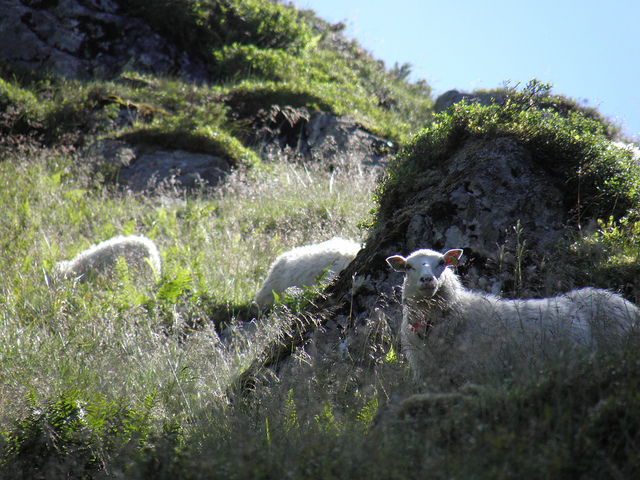What time of day does it look like in the photo? The photo seems to have been taken during the daytime, evidenced by the bright sunlight casting clear shadows and illuminating the landscape vibrantly. 